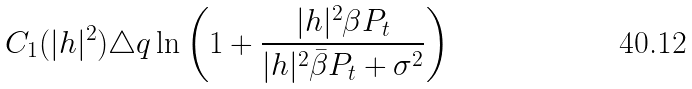<formula> <loc_0><loc_0><loc_500><loc_500>C _ { 1 } ( | h | ^ { 2 } ) \triangle q \ln \left ( 1 + \frac { | h | ^ { 2 } \beta P _ { t } } { | h | ^ { 2 } \bar { \beta } P _ { t } + \sigma ^ { 2 } } \right )</formula> 